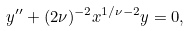<formula> <loc_0><loc_0><loc_500><loc_500>y ^ { \prime \prime } + ( 2 \nu ) ^ { - 2 } x ^ { 1 / \nu - 2 } y = 0 ,</formula> 